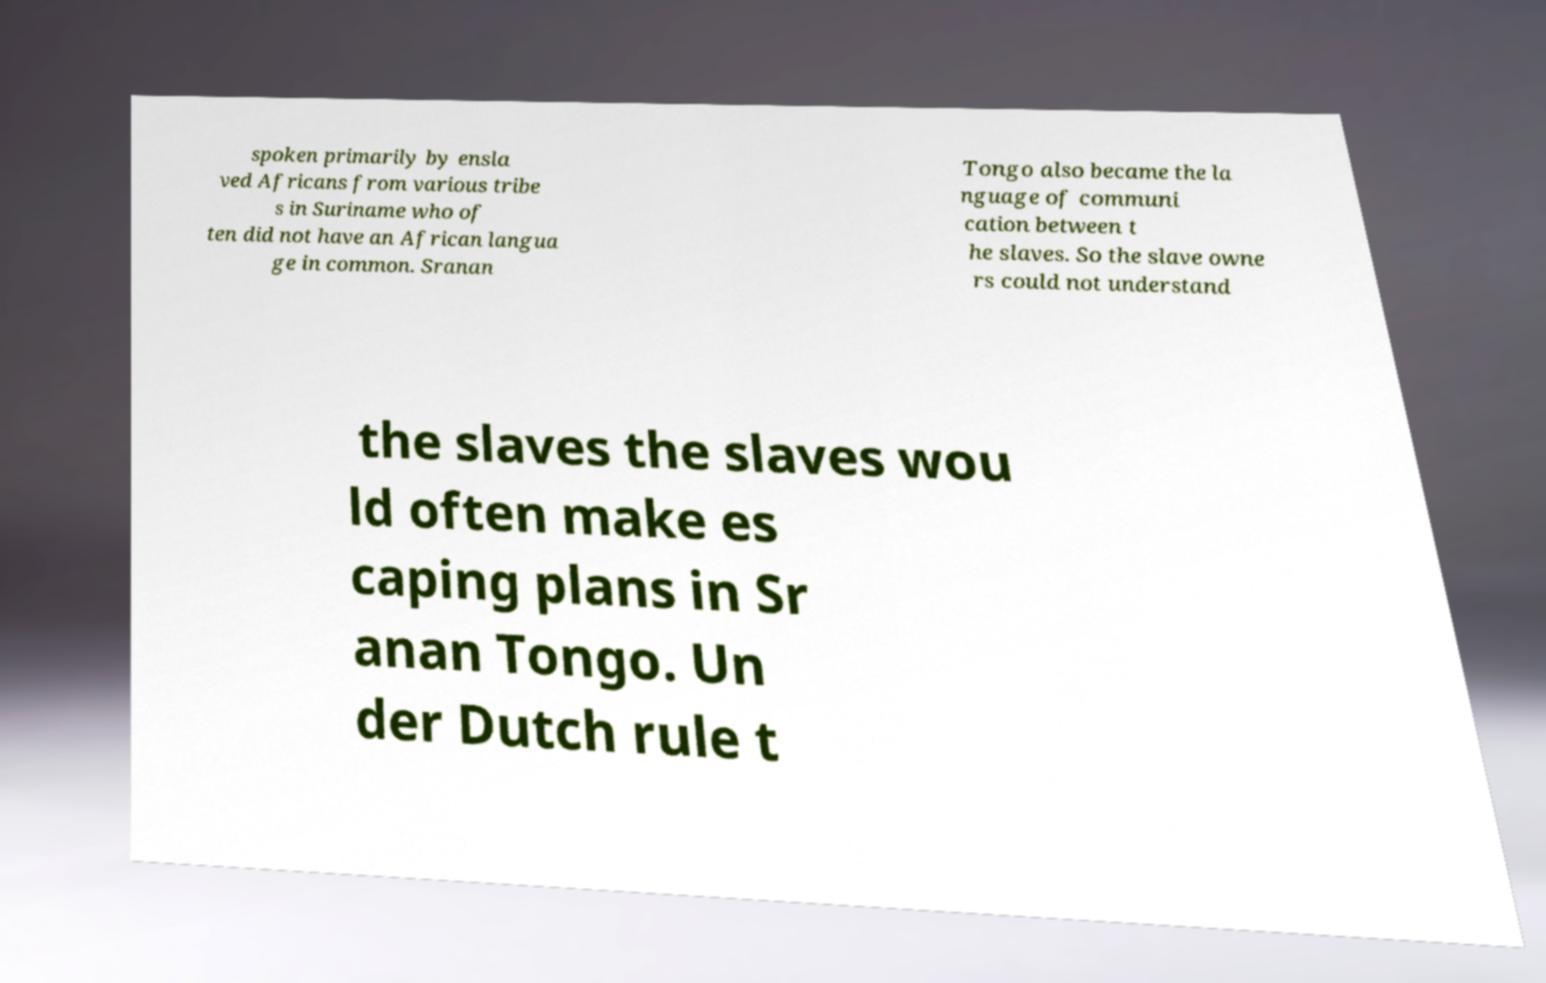There's text embedded in this image that I need extracted. Can you transcribe it verbatim? spoken primarily by ensla ved Africans from various tribe s in Suriname who of ten did not have an African langua ge in common. Sranan Tongo also became the la nguage of communi cation between t he slaves. So the slave owne rs could not understand the slaves the slaves wou ld often make es caping plans in Sr anan Tongo. Un der Dutch rule t 